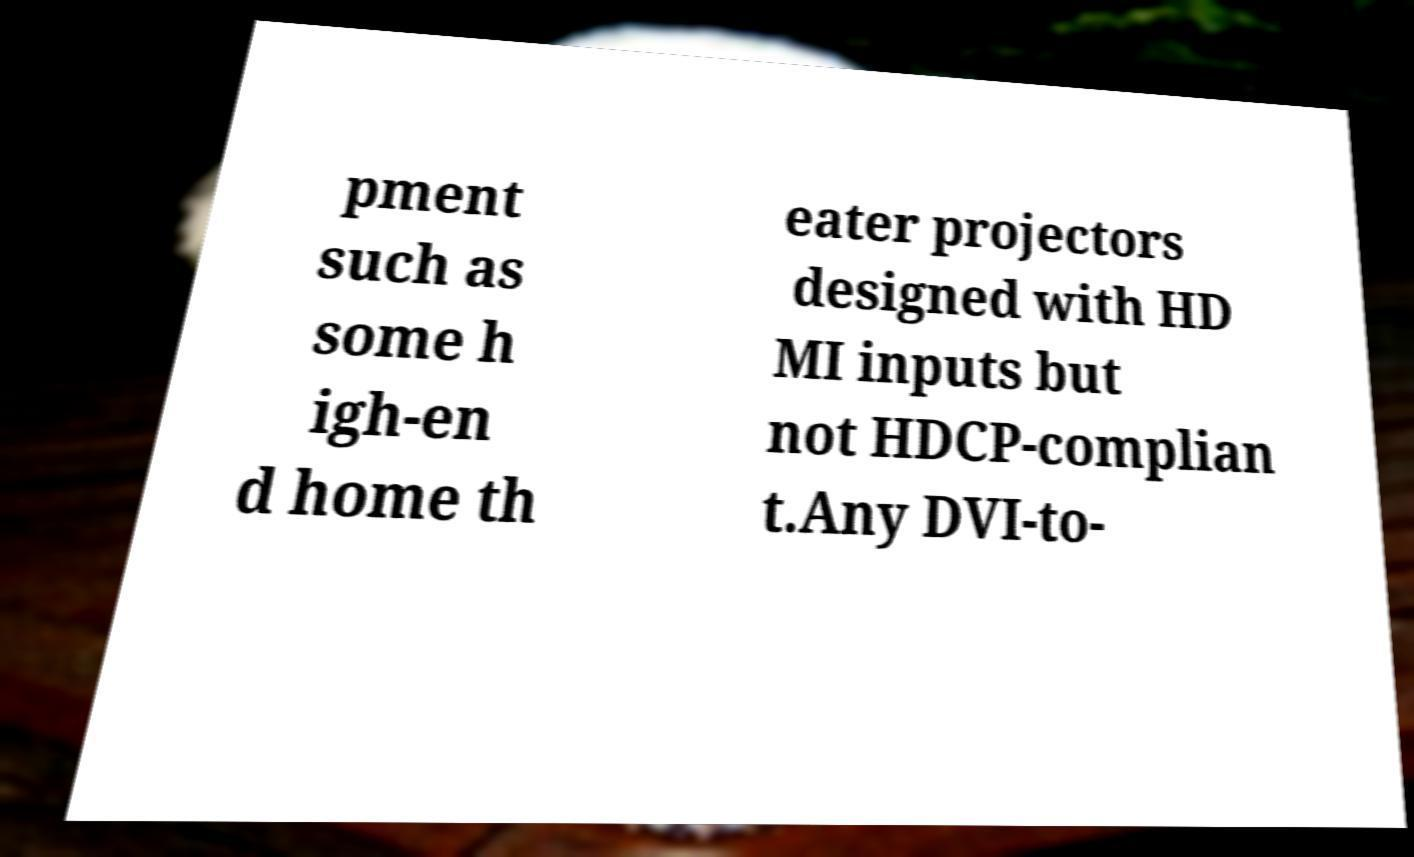Please identify and transcribe the text found in this image. pment such as some h igh-en d home th eater projectors designed with HD MI inputs but not HDCP-complian t.Any DVI-to- 